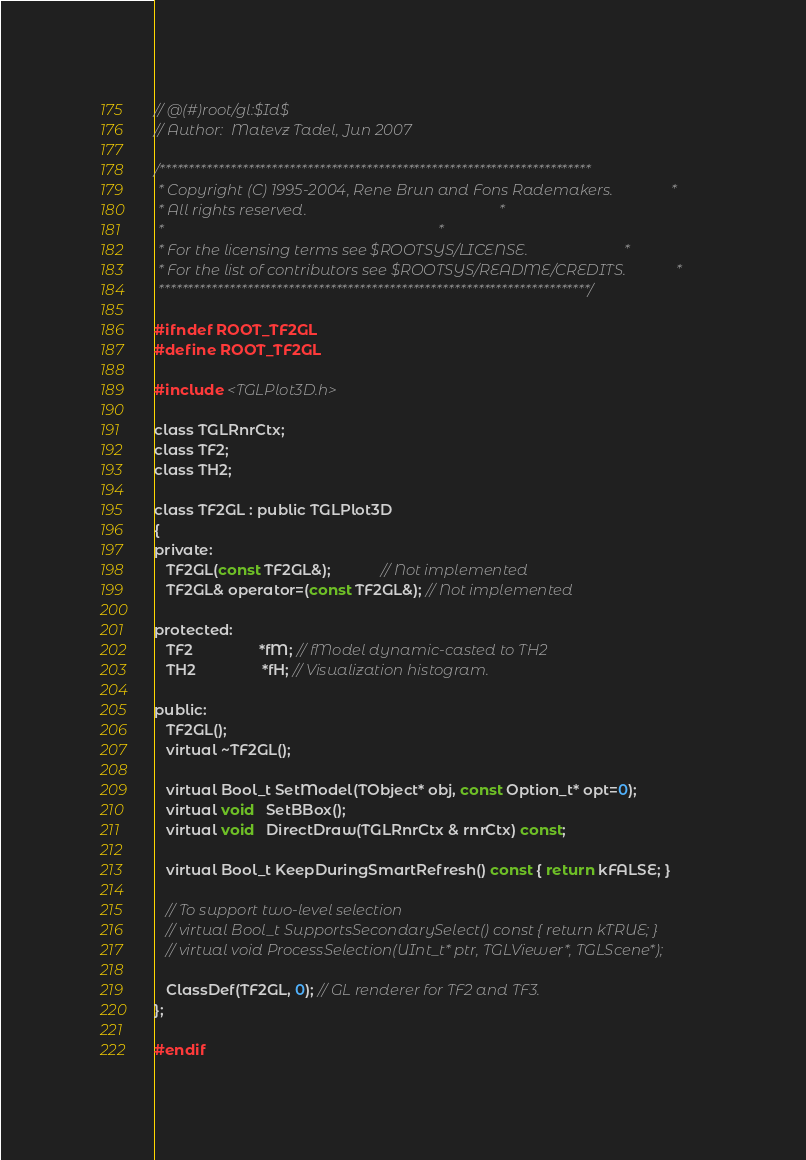<code> <loc_0><loc_0><loc_500><loc_500><_C_>// @(#)root/gl:$Id$
// Author:  Matevz Tadel, Jun 2007

/*************************************************************************
 * Copyright (C) 1995-2004, Rene Brun and Fons Rademakers.               *
 * All rights reserved.                                                  *
 *                                                                       *
 * For the licensing terms see $ROOTSYS/LICENSE.                         *
 * For the list of contributors see $ROOTSYS/README/CREDITS.             *
 *************************************************************************/

#ifndef ROOT_TF2GL
#define ROOT_TF2GL

#include <TGLPlot3D.h>

class TGLRnrCtx;
class TF2;
class TH2;

class TF2GL : public TGLPlot3D
{
private:
   TF2GL(const TF2GL&);            // Not implemented
   TF2GL& operator=(const TF2GL&); // Not implemented

protected:
   TF2                *fM; // fModel dynamic-casted to TH2
   TH2                *fH; // Visualization histogram.

public:
   TF2GL();
   virtual ~TF2GL();

   virtual Bool_t SetModel(TObject* obj, const Option_t* opt=0);
   virtual void   SetBBox();
   virtual void   DirectDraw(TGLRnrCtx & rnrCtx) const;

   virtual Bool_t KeepDuringSmartRefresh() const { return kFALSE; }

   // To support two-level selection
   // virtual Bool_t SupportsSecondarySelect() const { return kTRUE; }
   // virtual void ProcessSelection(UInt_t* ptr, TGLViewer*, TGLScene*);

   ClassDef(TF2GL, 0); // GL renderer for TF2 and TF3.
};

#endif
</code> 